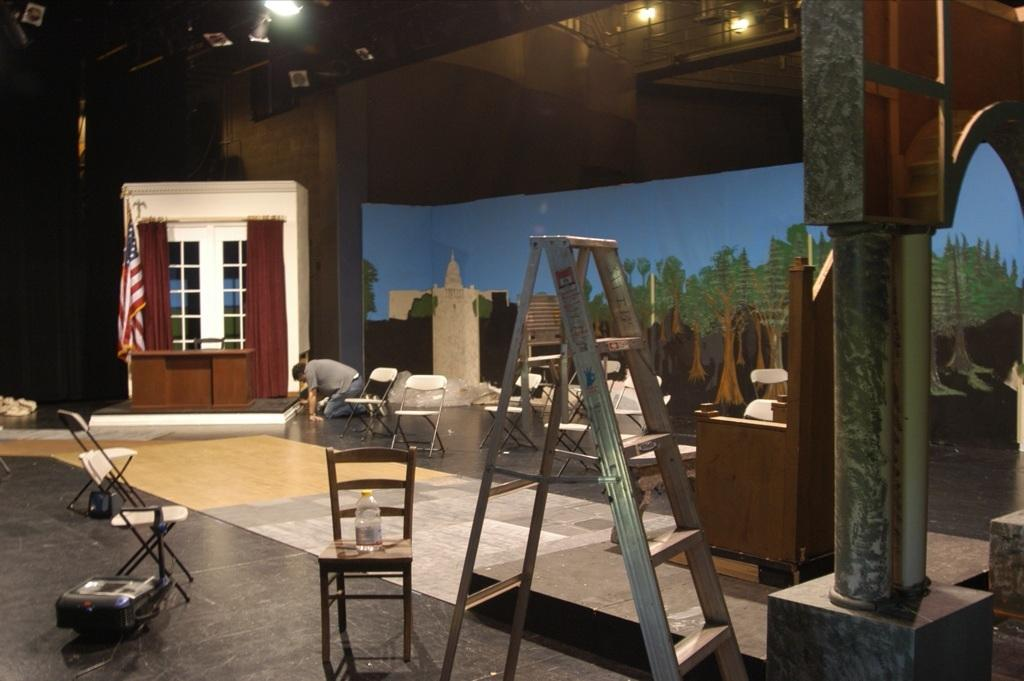What type of furniture is present in the image? There is a wooden chair and additional chairs in the image. What object is used for climbing in the image? There is a ladder in the image. What is the person in the image holding? There is a bottle in the image. What architectural feature can be seen in the image? There is a pillar in the image. What is the person in the image doing? There is a person in the image, but their specific activity is not mentioned in the facts. What is hanging on the wall in the background of the image? There is a poster on a wall in the background of the image. What type of window treatment is present in the image? There are curtains in the image. What type of lighting is present in the image? There are lights on the ceiling in the image. What is the flag associated with in the image? The facts do not specify the purpose or location of the flag in the image. How many beds are visible in the image? There are no beds present in the image. What type of chair is the person sitting on in the image? The facts do not mention the person sitting on a chair, nor do they specify the type of chair in the image. 